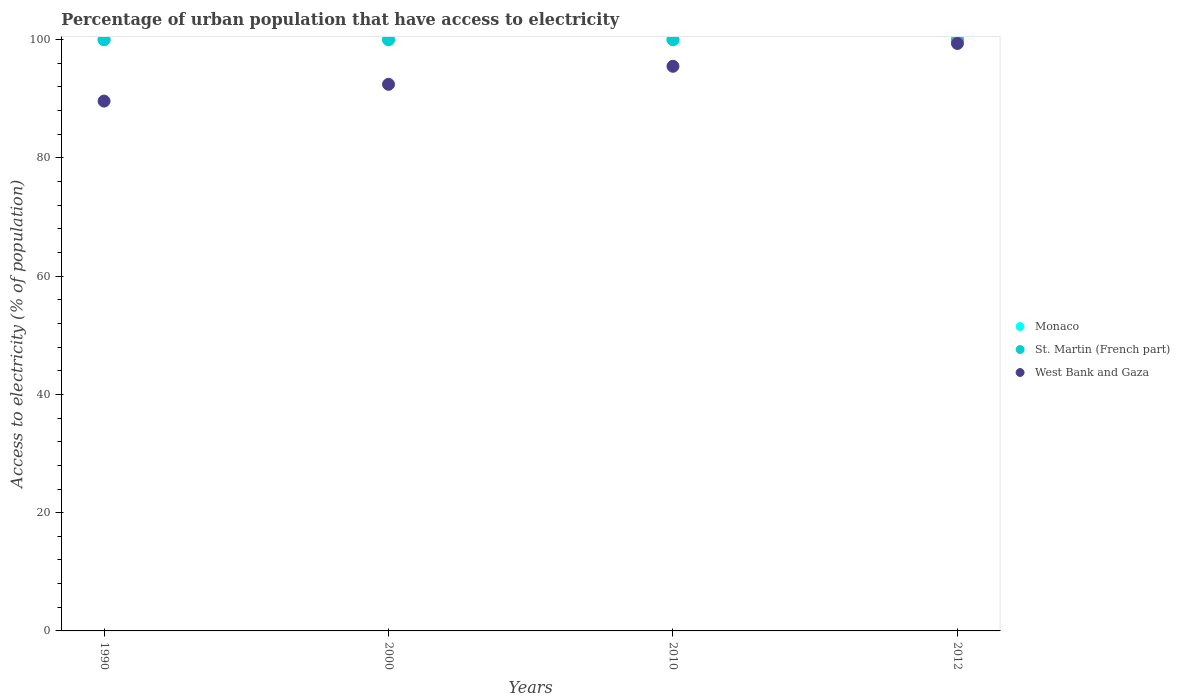Is the number of dotlines equal to the number of legend labels?
Your response must be concise. Yes. What is the percentage of urban population that have access to electricity in West Bank and Gaza in 2010?
Your answer should be compact. 95.5. Across all years, what is the maximum percentage of urban population that have access to electricity in West Bank and Gaza?
Give a very brief answer. 99.35. Across all years, what is the minimum percentage of urban population that have access to electricity in Monaco?
Make the answer very short. 100. In which year was the percentage of urban population that have access to electricity in St. Martin (French part) maximum?
Your response must be concise. 1990. What is the total percentage of urban population that have access to electricity in Monaco in the graph?
Keep it short and to the point. 400. What is the difference between the percentage of urban population that have access to electricity in Monaco in 2010 and that in 2012?
Offer a terse response. 0. What is the difference between the percentage of urban population that have access to electricity in West Bank and Gaza in 2000 and the percentage of urban population that have access to electricity in St. Martin (French part) in 1990?
Ensure brevity in your answer.  -7.55. What is the average percentage of urban population that have access to electricity in West Bank and Gaza per year?
Your response must be concise. 94.22. In the year 2012, what is the difference between the percentage of urban population that have access to electricity in St. Martin (French part) and percentage of urban population that have access to electricity in Monaco?
Provide a succinct answer. 0. In how many years, is the percentage of urban population that have access to electricity in St. Martin (French part) greater than 16 %?
Give a very brief answer. 4. What is the ratio of the percentage of urban population that have access to electricity in West Bank and Gaza in 1990 to that in 2012?
Make the answer very short. 0.9. Is the percentage of urban population that have access to electricity in St. Martin (French part) in 2010 less than that in 2012?
Offer a very short reply. No. Is the difference between the percentage of urban population that have access to electricity in St. Martin (French part) in 2000 and 2012 greater than the difference between the percentage of urban population that have access to electricity in Monaco in 2000 and 2012?
Ensure brevity in your answer.  No. What is the difference between the highest and the second highest percentage of urban population that have access to electricity in St. Martin (French part)?
Your answer should be very brief. 0. What is the difference between the highest and the lowest percentage of urban population that have access to electricity in Monaco?
Keep it short and to the point. 0. Does the percentage of urban population that have access to electricity in Monaco monotonically increase over the years?
Make the answer very short. No. Is the percentage of urban population that have access to electricity in Monaco strictly greater than the percentage of urban population that have access to electricity in West Bank and Gaza over the years?
Your response must be concise. Yes. Is the percentage of urban population that have access to electricity in West Bank and Gaza strictly less than the percentage of urban population that have access to electricity in St. Martin (French part) over the years?
Offer a very short reply. Yes. How many years are there in the graph?
Provide a short and direct response. 4. Are the values on the major ticks of Y-axis written in scientific E-notation?
Provide a succinct answer. No. Does the graph contain any zero values?
Keep it short and to the point. No. Does the graph contain grids?
Offer a very short reply. No. How are the legend labels stacked?
Your answer should be compact. Vertical. What is the title of the graph?
Offer a very short reply. Percentage of urban population that have access to electricity. What is the label or title of the Y-axis?
Offer a terse response. Access to electricity (% of population). What is the Access to electricity (% of population) in West Bank and Gaza in 1990?
Your response must be concise. 89.61. What is the Access to electricity (% of population) of St. Martin (French part) in 2000?
Your answer should be very brief. 100. What is the Access to electricity (% of population) in West Bank and Gaza in 2000?
Your response must be concise. 92.45. What is the Access to electricity (% of population) of St. Martin (French part) in 2010?
Offer a very short reply. 100. What is the Access to electricity (% of population) in West Bank and Gaza in 2010?
Offer a very short reply. 95.5. What is the Access to electricity (% of population) in St. Martin (French part) in 2012?
Provide a succinct answer. 100. What is the Access to electricity (% of population) in West Bank and Gaza in 2012?
Make the answer very short. 99.35. Across all years, what is the maximum Access to electricity (% of population) in Monaco?
Give a very brief answer. 100. Across all years, what is the maximum Access to electricity (% of population) in St. Martin (French part)?
Offer a very short reply. 100. Across all years, what is the maximum Access to electricity (% of population) of West Bank and Gaza?
Your answer should be compact. 99.35. Across all years, what is the minimum Access to electricity (% of population) in Monaco?
Offer a terse response. 100. Across all years, what is the minimum Access to electricity (% of population) in West Bank and Gaza?
Give a very brief answer. 89.61. What is the total Access to electricity (% of population) in Monaco in the graph?
Your answer should be very brief. 400. What is the total Access to electricity (% of population) in St. Martin (French part) in the graph?
Provide a succinct answer. 400. What is the total Access to electricity (% of population) of West Bank and Gaza in the graph?
Your answer should be compact. 376.9. What is the difference between the Access to electricity (% of population) of Monaco in 1990 and that in 2000?
Your answer should be compact. 0. What is the difference between the Access to electricity (% of population) of West Bank and Gaza in 1990 and that in 2000?
Your response must be concise. -2.84. What is the difference between the Access to electricity (% of population) in St. Martin (French part) in 1990 and that in 2010?
Offer a terse response. 0. What is the difference between the Access to electricity (% of population) in West Bank and Gaza in 1990 and that in 2010?
Give a very brief answer. -5.89. What is the difference between the Access to electricity (% of population) of Monaco in 1990 and that in 2012?
Offer a very short reply. 0. What is the difference between the Access to electricity (% of population) in St. Martin (French part) in 1990 and that in 2012?
Provide a short and direct response. 0. What is the difference between the Access to electricity (% of population) in West Bank and Gaza in 1990 and that in 2012?
Give a very brief answer. -9.74. What is the difference between the Access to electricity (% of population) of Monaco in 2000 and that in 2010?
Give a very brief answer. 0. What is the difference between the Access to electricity (% of population) of West Bank and Gaza in 2000 and that in 2010?
Give a very brief answer. -3.05. What is the difference between the Access to electricity (% of population) in St. Martin (French part) in 2000 and that in 2012?
Provide a succinct answer. 0. What is the difference between the Access to electricity (% of population) of West Bank and Gaza in 2000 and that in 2012?
Offer a terse response. -6.9. What is the difference between the Access to electricity (% of population) of Monaco in 2010 and that in 2012?
Offer a very short reply. 0. What is the difference between the Access to electricity (% of population) in St. Martin (French part) in 2010 and that in 2012?
Give a very brief answer. 0. What is the difference between the Access to electricity (% of population) in West Bank and Gaza in 2010 and that in 2012?
Provide a short and direct response. -3.85. What is the difference between the Access to electricity (% of population) in Monaco in 1990 and the Access to electricity (% of population) in West Bank and Gaza in 2000?
Offer a very short reply. 7.55. What is the difference between the Access to electricity (% of population) of St. Martin (French part) in 1990 and the Access to electricity (% of population) of West Bank and Gaza in 2000?
Offer a very short reply. 7.55. What is the difference between the Access to electricity (% of population) of Monaco in 1990 and the Access to electricity (% of population) of West Bank and Gaza in 2010?
Make the answer very short. 4.5. What is the difference between the Access to electricity (% of population) in St. Martin (French part) in 1990 and the Access to electricity (% of population) in West Bank and Gaza in 2010?
Provide a short and direct response. 4.5. What is the difference between the Access to electricity (% of population) of Monaco in 1990 and the Access to electricity (% of population) of St. Martin (French part) in 2012?
Offer a very short reply. 0. What is the difference between the Access to electricity (% of population) in Monaco in 1990 and the Access to electricity (% of population) in West Bank and Gaza in 2012?
Your answer should be compact. 0.65. What is the difference between the Access to electricity (% of population) in St. Martin (French part) in 1990 and the Access to electricity (% of population) in West Bank and Gaza in 2012?
Make the answer very short. 0.65. What is the difference between the Access to electricity (% of population) of Monaco in 2000 and the Access to electricity (% of population) of West Bank and Gaza in 2010?
Make the answer very short. 4.5. What is the difference between the Access to electricity (% of population) of St. Martin (French part) in 2000 and the Access to electricity (% of population) of West Bank and Gaza in 2010?
Keep it short and to the point. 4.5. What is the difference between the Access to electricity (% of population) in Monaco in 2000 and the Access to electricity (% of population) in St. Martin (French part) in 2012?
Keep it short and to the point. 0. What is the difference between the Access to electricity (% of population) in Monaco in 2000 and the Access to electricity (% of population) in West Bank and Gaza in 2012?
Your answer should be compact. 0.65. What is the difference between the Access to electricity (% of population) of St. Martin (French part) in 2000 and the Access to electricity (% of population) of West Bank and Gaza in 2012?
Provide a short and direct response. 0.65. What is the difference between the Access to electricity (% of population) in Monaco in 2010 and the Access to electricity (% of population) in St. Martin (French part) in 2012?
Ensure brevity in your answer.  0. What is the difference between the Access to electricity (% of population) in Monaco in 2010 and the Access to electricity (% of population) in West Bank and Gaza in 2012?
Make the answer very short. 0.65. What is the difference between the Access to electricity (% of population) of St. Martin (French part) in 2010 and the Access to electricity (% of population) of West Bank and Gaza in 2012?
Provide a succinct answer. 0.65. What is the average Access to electricity (% of population) in West Bank and Gaza per year?
Your answer should be very brief. 94.22. In the year 1990, what is the difference between the Access to electricity (% of population) in Monaco and Access to electricity (% of population) in St. Martin (French part)?
Provide a succinct answer. 0. In the year 1990, what is the difference between the Access to electricity (% of population) of Monaco and Access to electricity (% of population) of West Bank and Gaza?
Keep it short and to the point. 10.39. In the year 1990, what is the difference between the Access to electricity (% of population) of St. Martin (French part) and Access to electricity (% of population) of West Bank and Gaza?
Provide a succinct answer. 10.39. In the year 2000, what is the difference between the Access to electricity (% of population) in Monaco and Access to electricity (% of population) in St. Martin (French part)?
Offer a terse response. 0. In the year 2000, what is the difference between the Access to electricity (% of population) in Monaco and Access to electricity (% of population) in West Bank and Gaza?
Ensure brevity in your answer.  7.55. In the year 2000, what is the difference between the Access to electricity (% of population) in St. Martin (French part) and Access to electricity (% of population) in West Bank and Gaza?
Keep it short and to the point. 7.55. In the year 2010, what is the difference between the Access to electricity (% of population) in Monaco and Access to electricity (% of population) in St. Martin (French part)?
Offer a very short reply. 0. In the year 2010, what is the difference between the Access to electricity (% of population) in Monaco and Access to electricity (% of population) in West Bank and Gaza?
Give a very brief answer. 4.5. In the year 2010, what is the difference between the Access to electricity (% of population) of St. Martin (French part) and Access to electricity (% of population) of West Bank and Gaza?
Offer a terse response. 4.5. In the year 2012, what is the difference between the Access to electricity (% of population) in Monaco and Access to electricity (% of population) in St. Martin (French part)?
Make the answer very short. 0. In the year 2012, what is the difference between the Access to electricity (% of population) in Monaco and Access to electricity (% of population) in West Bank and Gaza?
Provide a short and direct response. 0.65. In the year 2012, what is the difference between the Access to electricity (% of population) in St. Martin (French part) and Access to electricity (% of population) in West Bank and Gaza?
Provide a short and direct response. 0.65. What is the ratio of the Access to electricity (% of population) of West Bank and Gaza in 1990 to that in 2000?
Ensure brevity in your answer.  0.97. What is the ratio of the Access to electricity (% of population) of St. Martin (French part) in 1990 to that in 2010?
Your answer should be compact. 1. What is the ratio of the Access to electricity (% of population) of West Bank and Gaza in 1990 to that in 2010?
Ensure brevity in your answer.  0.94. What is the ratio of the Access to electricity (% of population) of West Bank and Gaza in 1990 to that in 2012?
Offer a terse response. 0.9. What is the ratio of the Access to electricity (% of population) in Monaco in 2000 to that in 2010?
Your answer should be compact. 1. What is the ratio of the Access to electricity (% of population) in St. Martin (French part) in 2000 to that in 2010?
Provide a succinct answer. 1. What is the ratio of the Access to electricity (% of population) in West Bank and Gaza in 2000 to that in 2010?
Give a very brief answer. 0.97. What is the ratio of the Access to electricity (% of population) in Monaco in 2000 to that in 2012?
Your answer should be very brief. 1. What is the ratio of the Access to electricity (% of population) of St. Martin (French part) in 2000 to that in 2012?
Keep it short and to the point. 1. What is the ratio of the Access to electricity (% of population) in West Bank and Gaza in 2000 to that in 2012?
Ensure brevity in your answer.  0.93. What is the ratio of the Access to electricity (% of population) of Monaco in 2010 to that in 2012?
Your answer should be very brief. 1. What is the ratio of the Access to electricity (% of population) in West Bank and Gaza in 2010 to that in 2012?
Keep it short and to the point. 0.96. What is the difference between the highest and the second highest Access to electricity (% of population) of West Bank and Gaza?
Keep it short and to the point. 3.85. What is the difference between the highest and the lowest Access to electricity (% of population) of West Bank and Gaza?
Offer a very short reply. 9.74. 